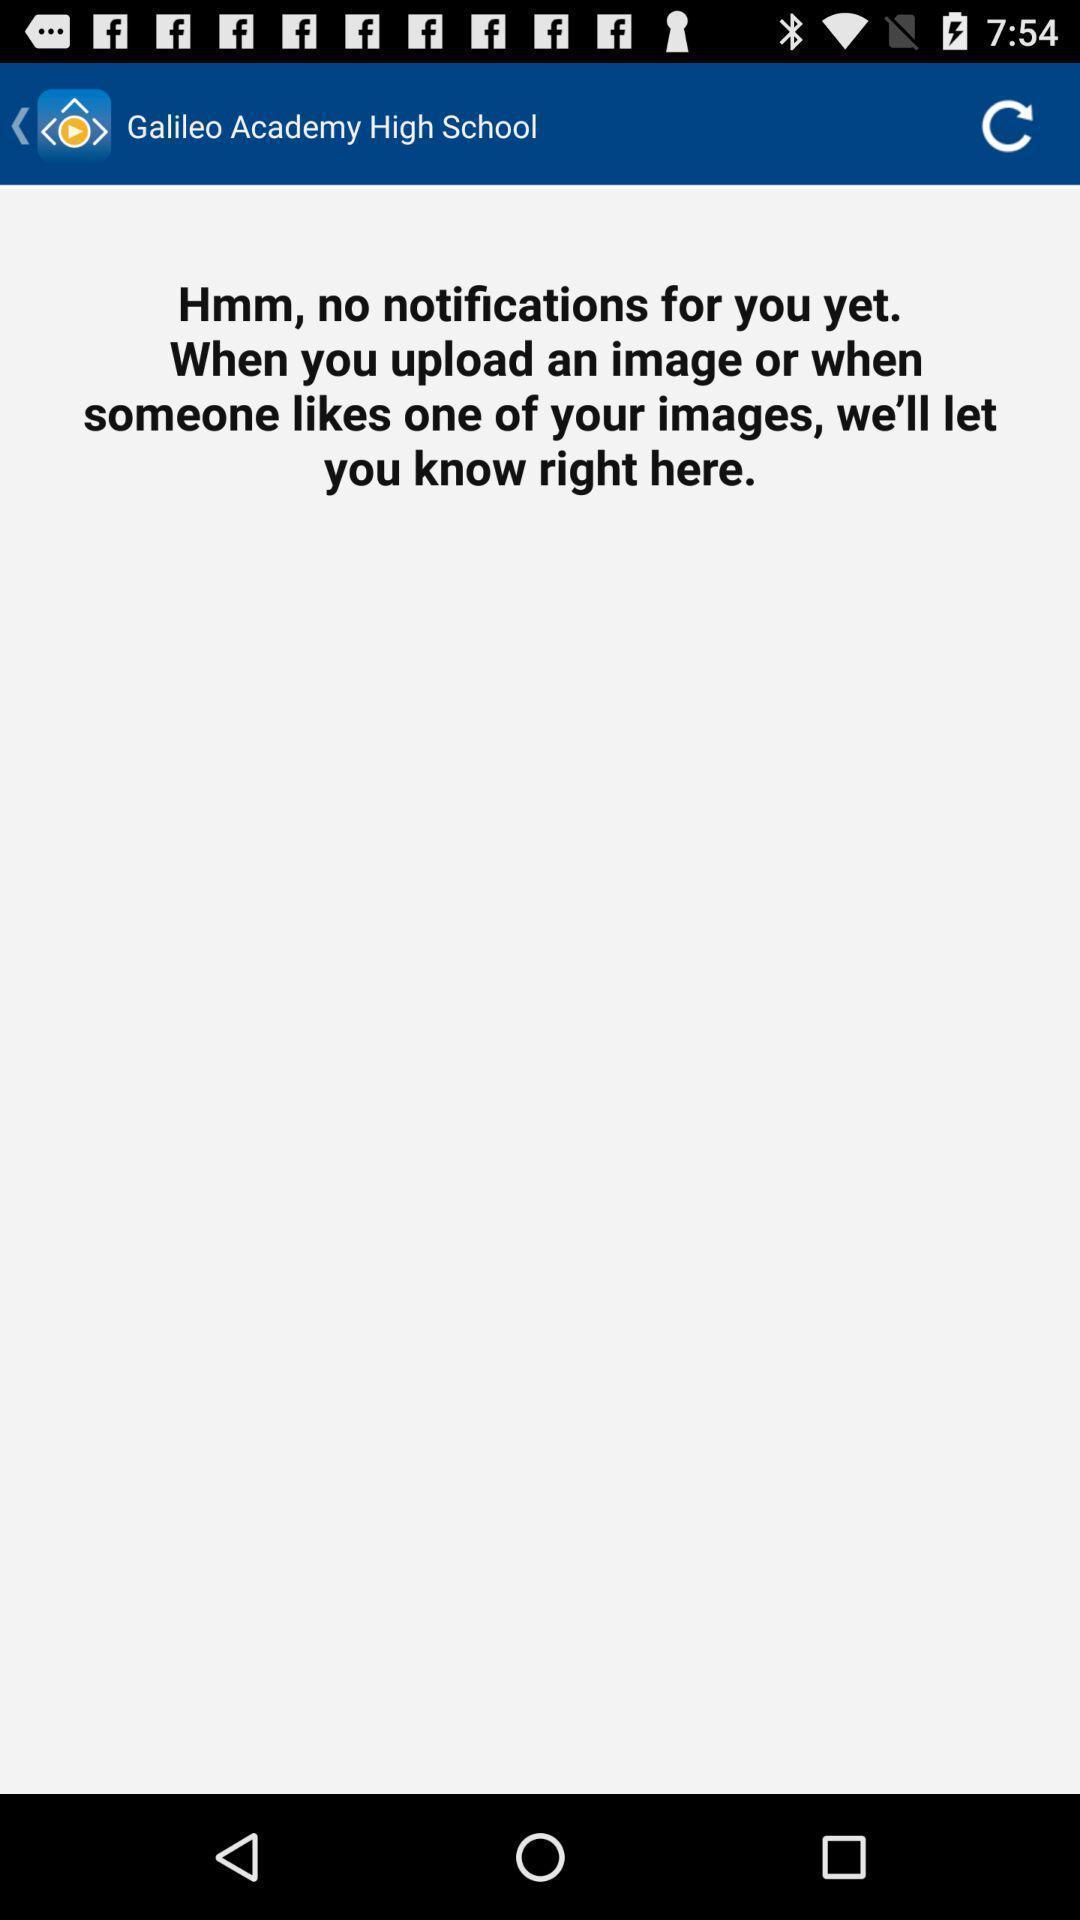Describe the content in this image. School page to upload images. 